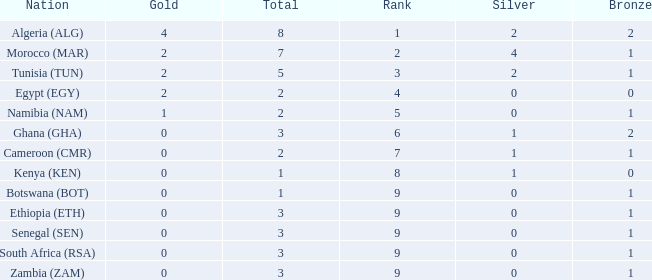What is the average Total with a Nation of ethiopia (eth) and a Rank that is larger than 9? None. 